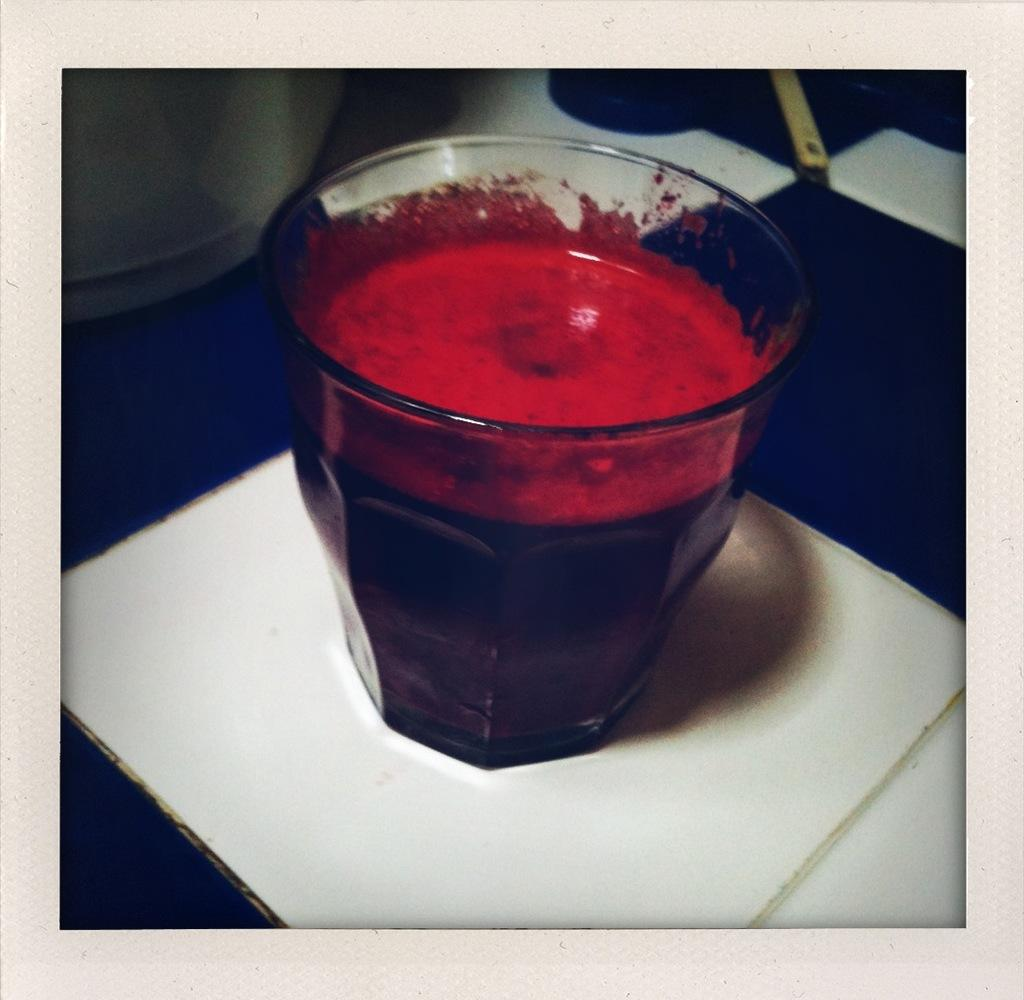What is in the glass that is visible in the image? The glass contains juice. What is the color of the surface on which the glass is placed? The surface is purple and white. How does the baby use the spoon in the image? There is no baby or spoon present in the image. 